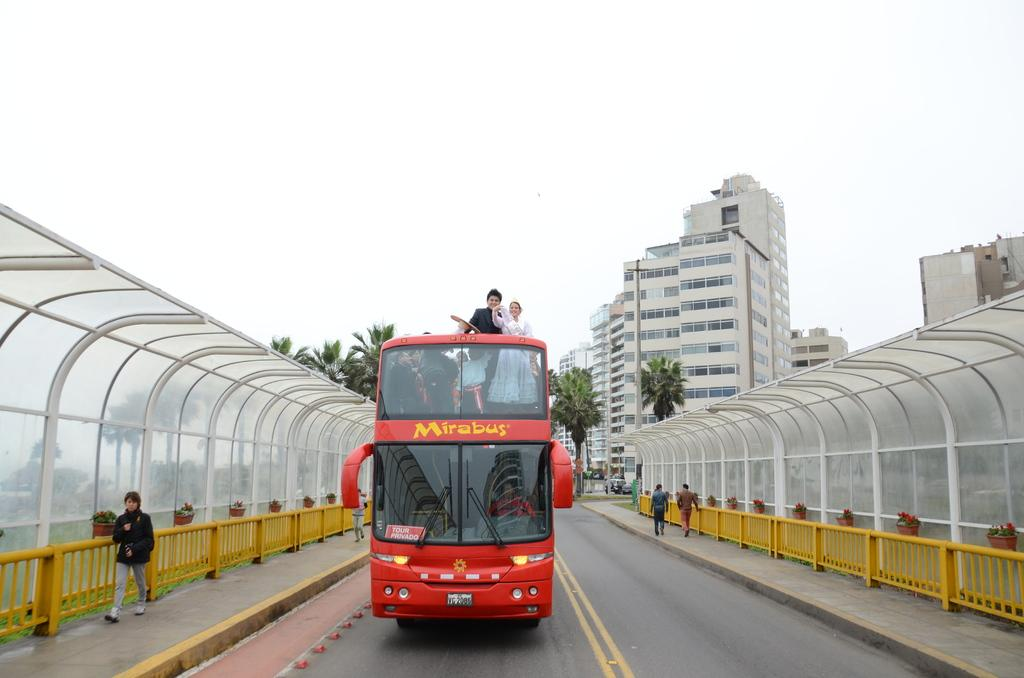<image>
Render a clear and concise summary of the photo. A double decker Mirabus has people standing on the upper level. 